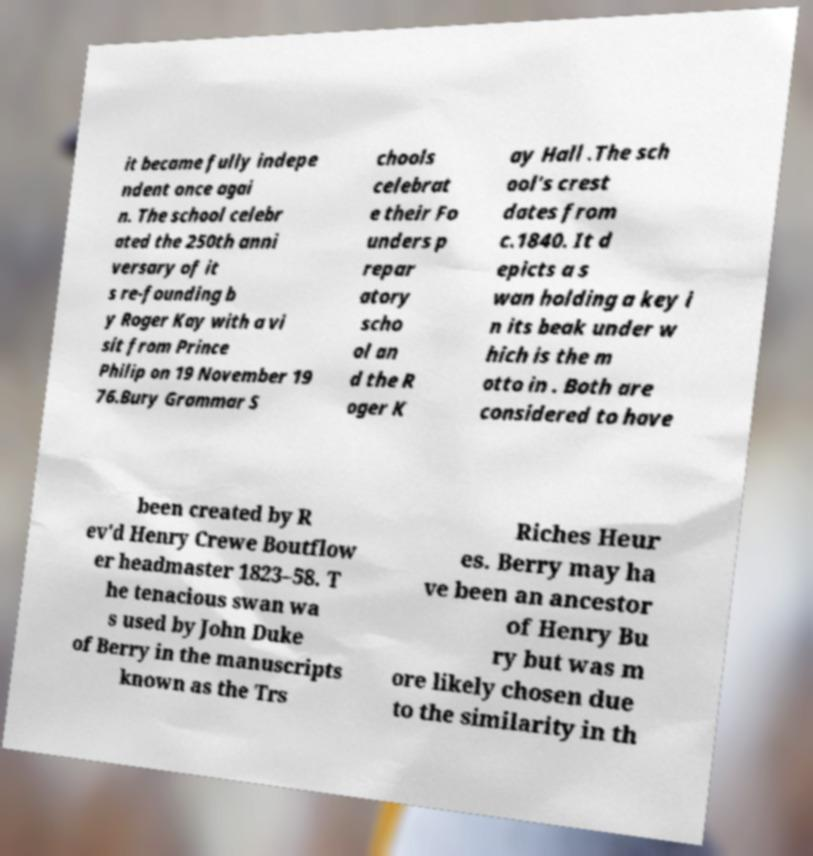For documentation purposes, I need the text within this image transcribed. Could you provide that? it became fully indepe ndent once agai n. The school celebr ated the 250th anni versary of it s re-founding b y Roger Kay with a vi sit from Prince Philip on 19 November 19 76.Bury Grammar S chools celebrat e their Fo unders p repar atory scho ol an d the R oger K ay Hall .The sch ool's crest dates from c.1840. It d epicts a s wan holding a key i n its beak under w hich is the m otto in . Both are considered to have been created by R ev'd Henry Crewe Boutflow er headmaster 1823–58. T he tenacious swan wa s used by John Duke of Berry in the manuscripts known as the Trs Riches Heur es. Berry may ha ve been an ancestor of Henry Bu ry but was m ore likely chosen due to the similarity in th 